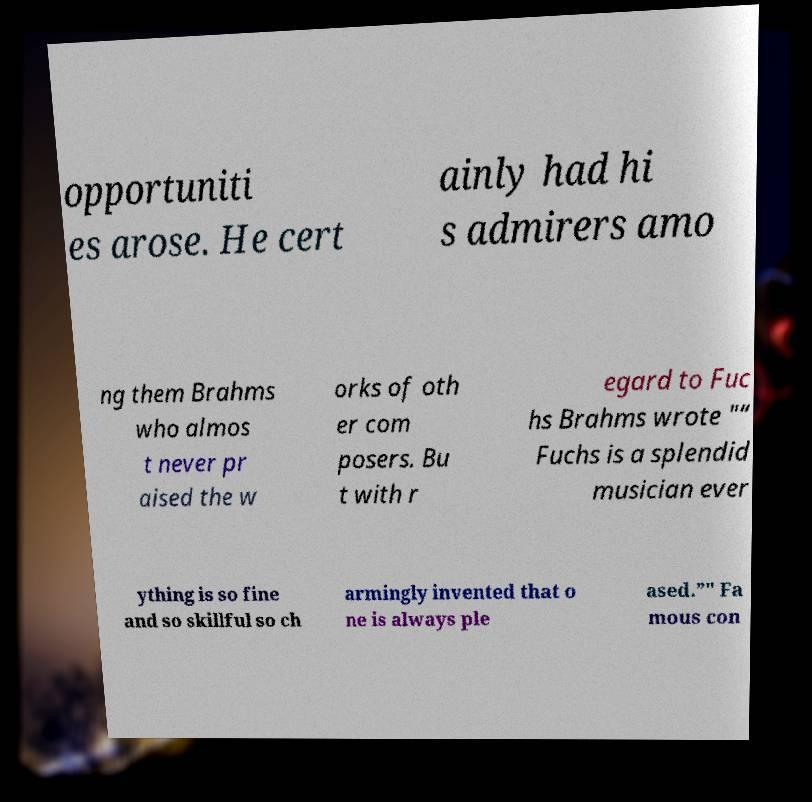For documentation purposes, I need the text within this image transcribed. Could you provide that? opportuniti es arose. He cert ainly had hi s admirers amo ng them Brahms who almos t never pr aised the w orks of oth er com posers. Bu t with r egard to Fuc hs Brahms wrote "“ Fuchs is a splendid musician ever ything is so fine and so skillful so ch armingly invented that o ne is always ple ased.”" Fa mous con 